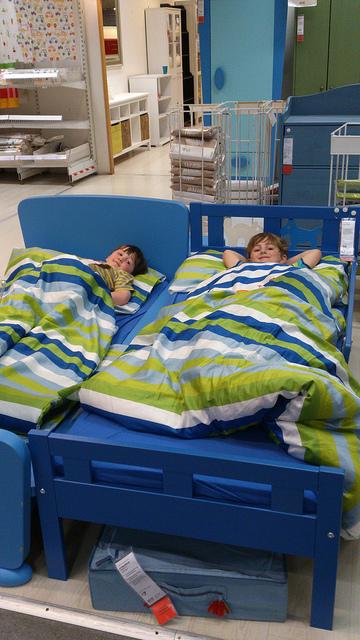Is this a store?
Be succinct. Yes. Are the boys sleeping?
Short answer required. No. Are the boys twins?
Short answer required. No. 